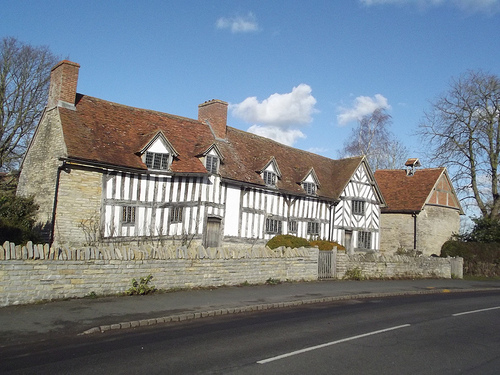<image>
Is the street under the house? No. The street is not positioned under the house. The vertical relationship between these objects is different. 